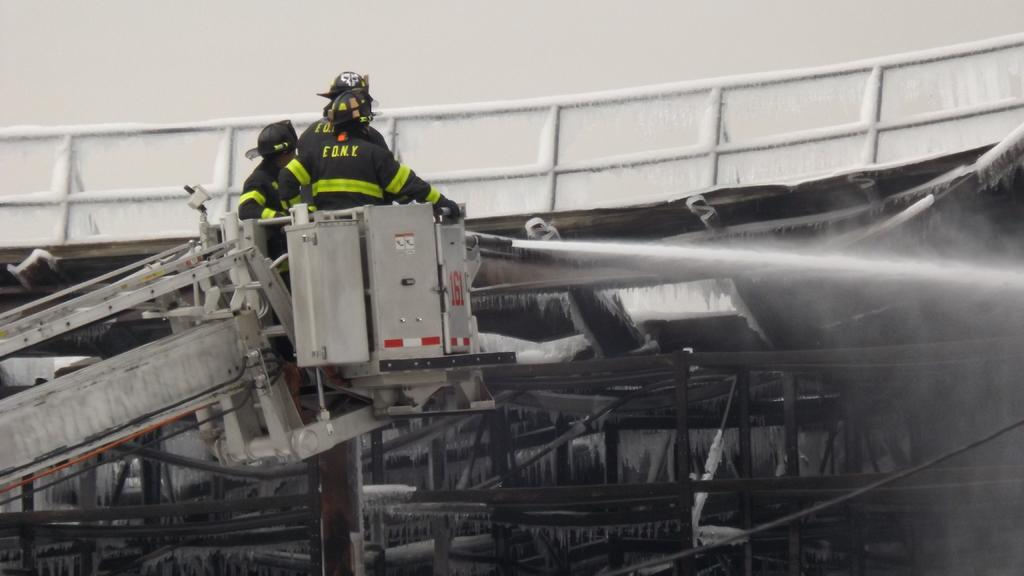How many people are in the image? There are three persons in the image. Where are the persons located? The persons are in a crane. What are the persons holding in the image? The persons are holding a water pipe. What safety feature can be seen in the image? There is a railing visible in the image. What type of hole can be seen in the image? There is no hole present in the image. What part of the crane is the persons talking to each other? The image does not show the persons talking to each other, so it cannot be determined which part of the crane they might be talking near. 